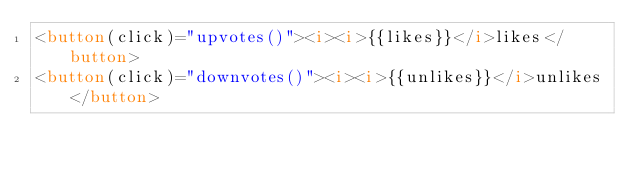Convert code to text. <code><loc_0><loc_0><loc_500><loc_500><_HTML_><button(click)="upvotes()"><i><i>{{likes}}</i>likes</button>
<button(click)="downvotes()"><i><i>{{unlikes}}</i>unlikes</button></code> 